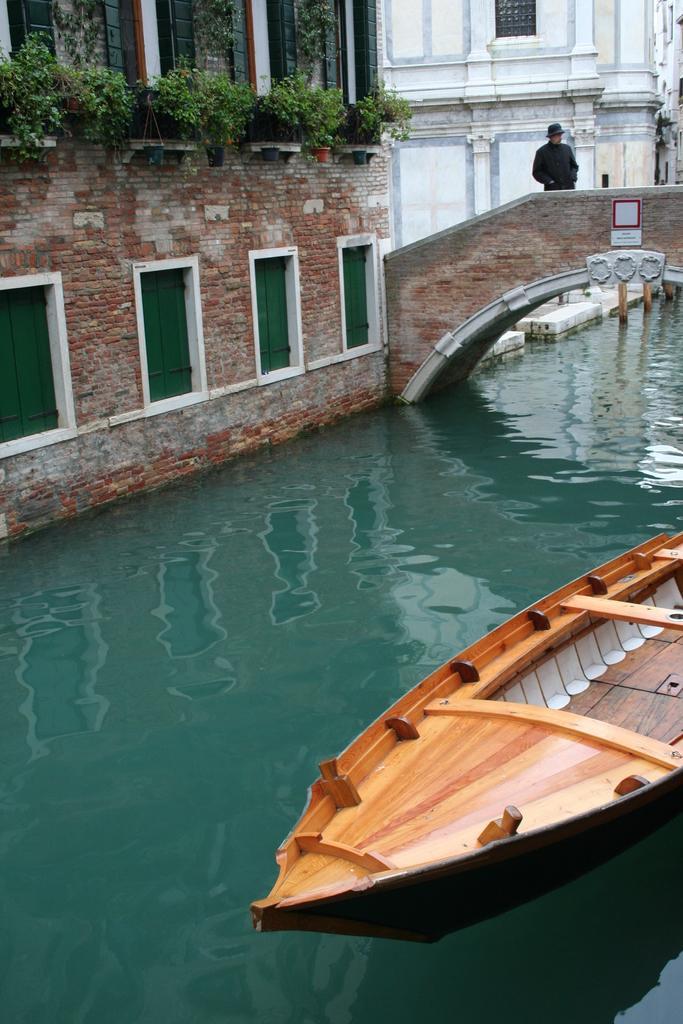How would you summarize this image in a sentence or two? In this picture there is a boat on the water at the bottom side of the image and there is a man who is standing on the bridge on the right side of the image and there are buildings in the background area of the image, there are windows on it and there are plants in the image. 